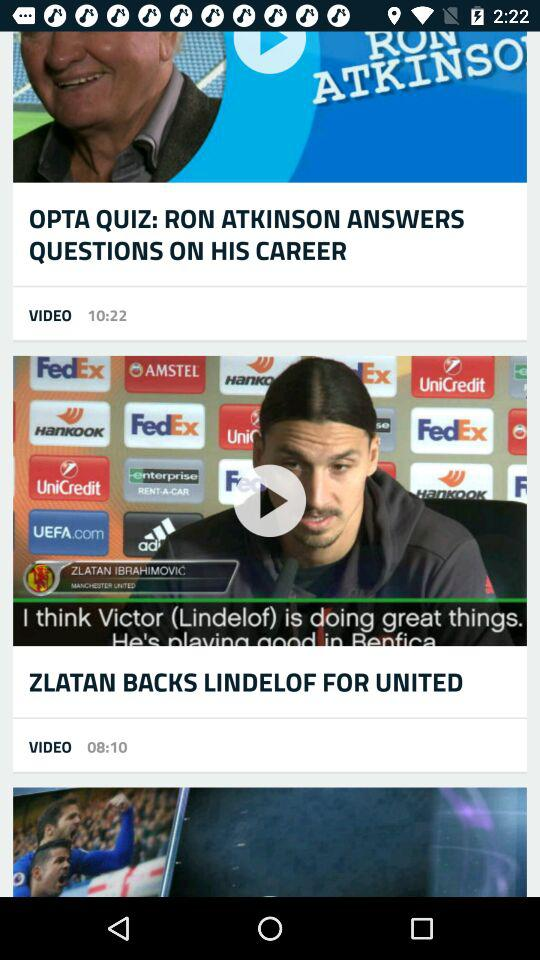What is the duration of the video "OPTA QUIZ: RON ATKINSON ANSWERS QUESTIONS ON HIS CAREER"? The duration of the video is 10:22. 